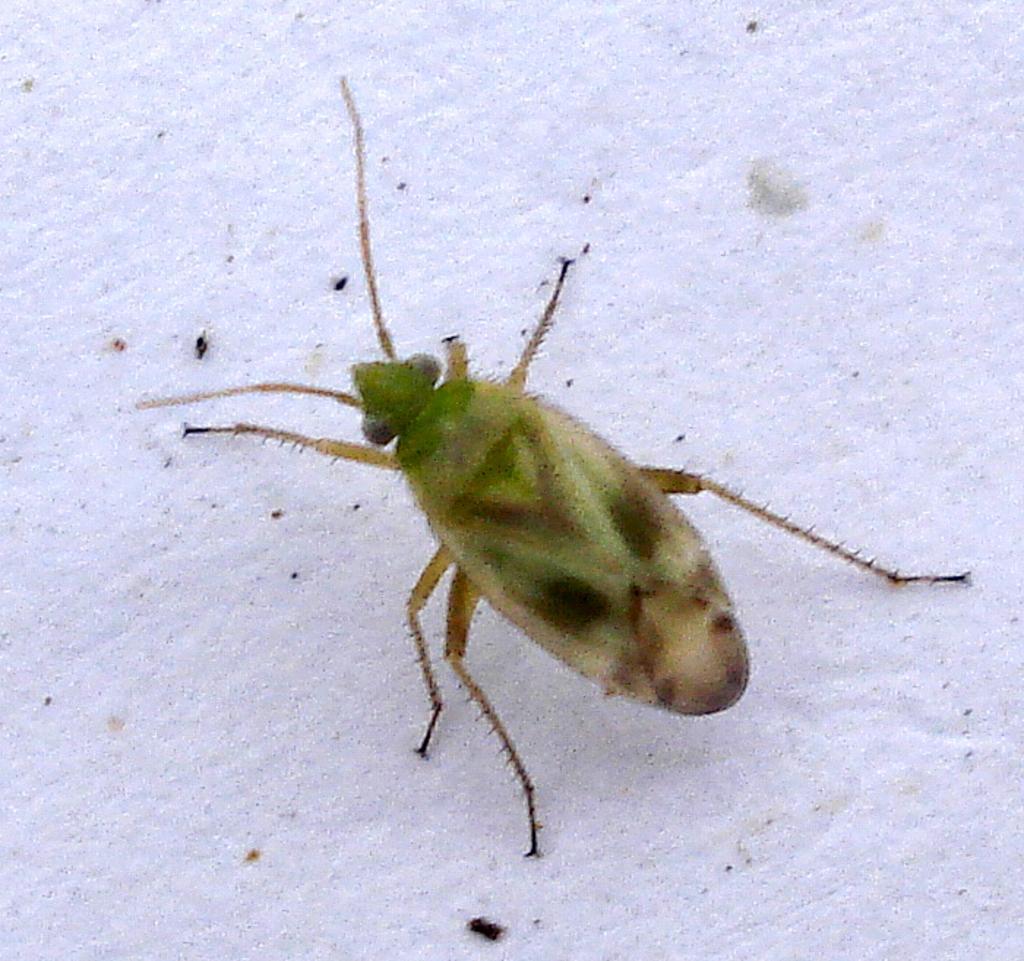Describe this image in one or two sentences. In this image I can see insect which is in brown and green color, background is in white color. 